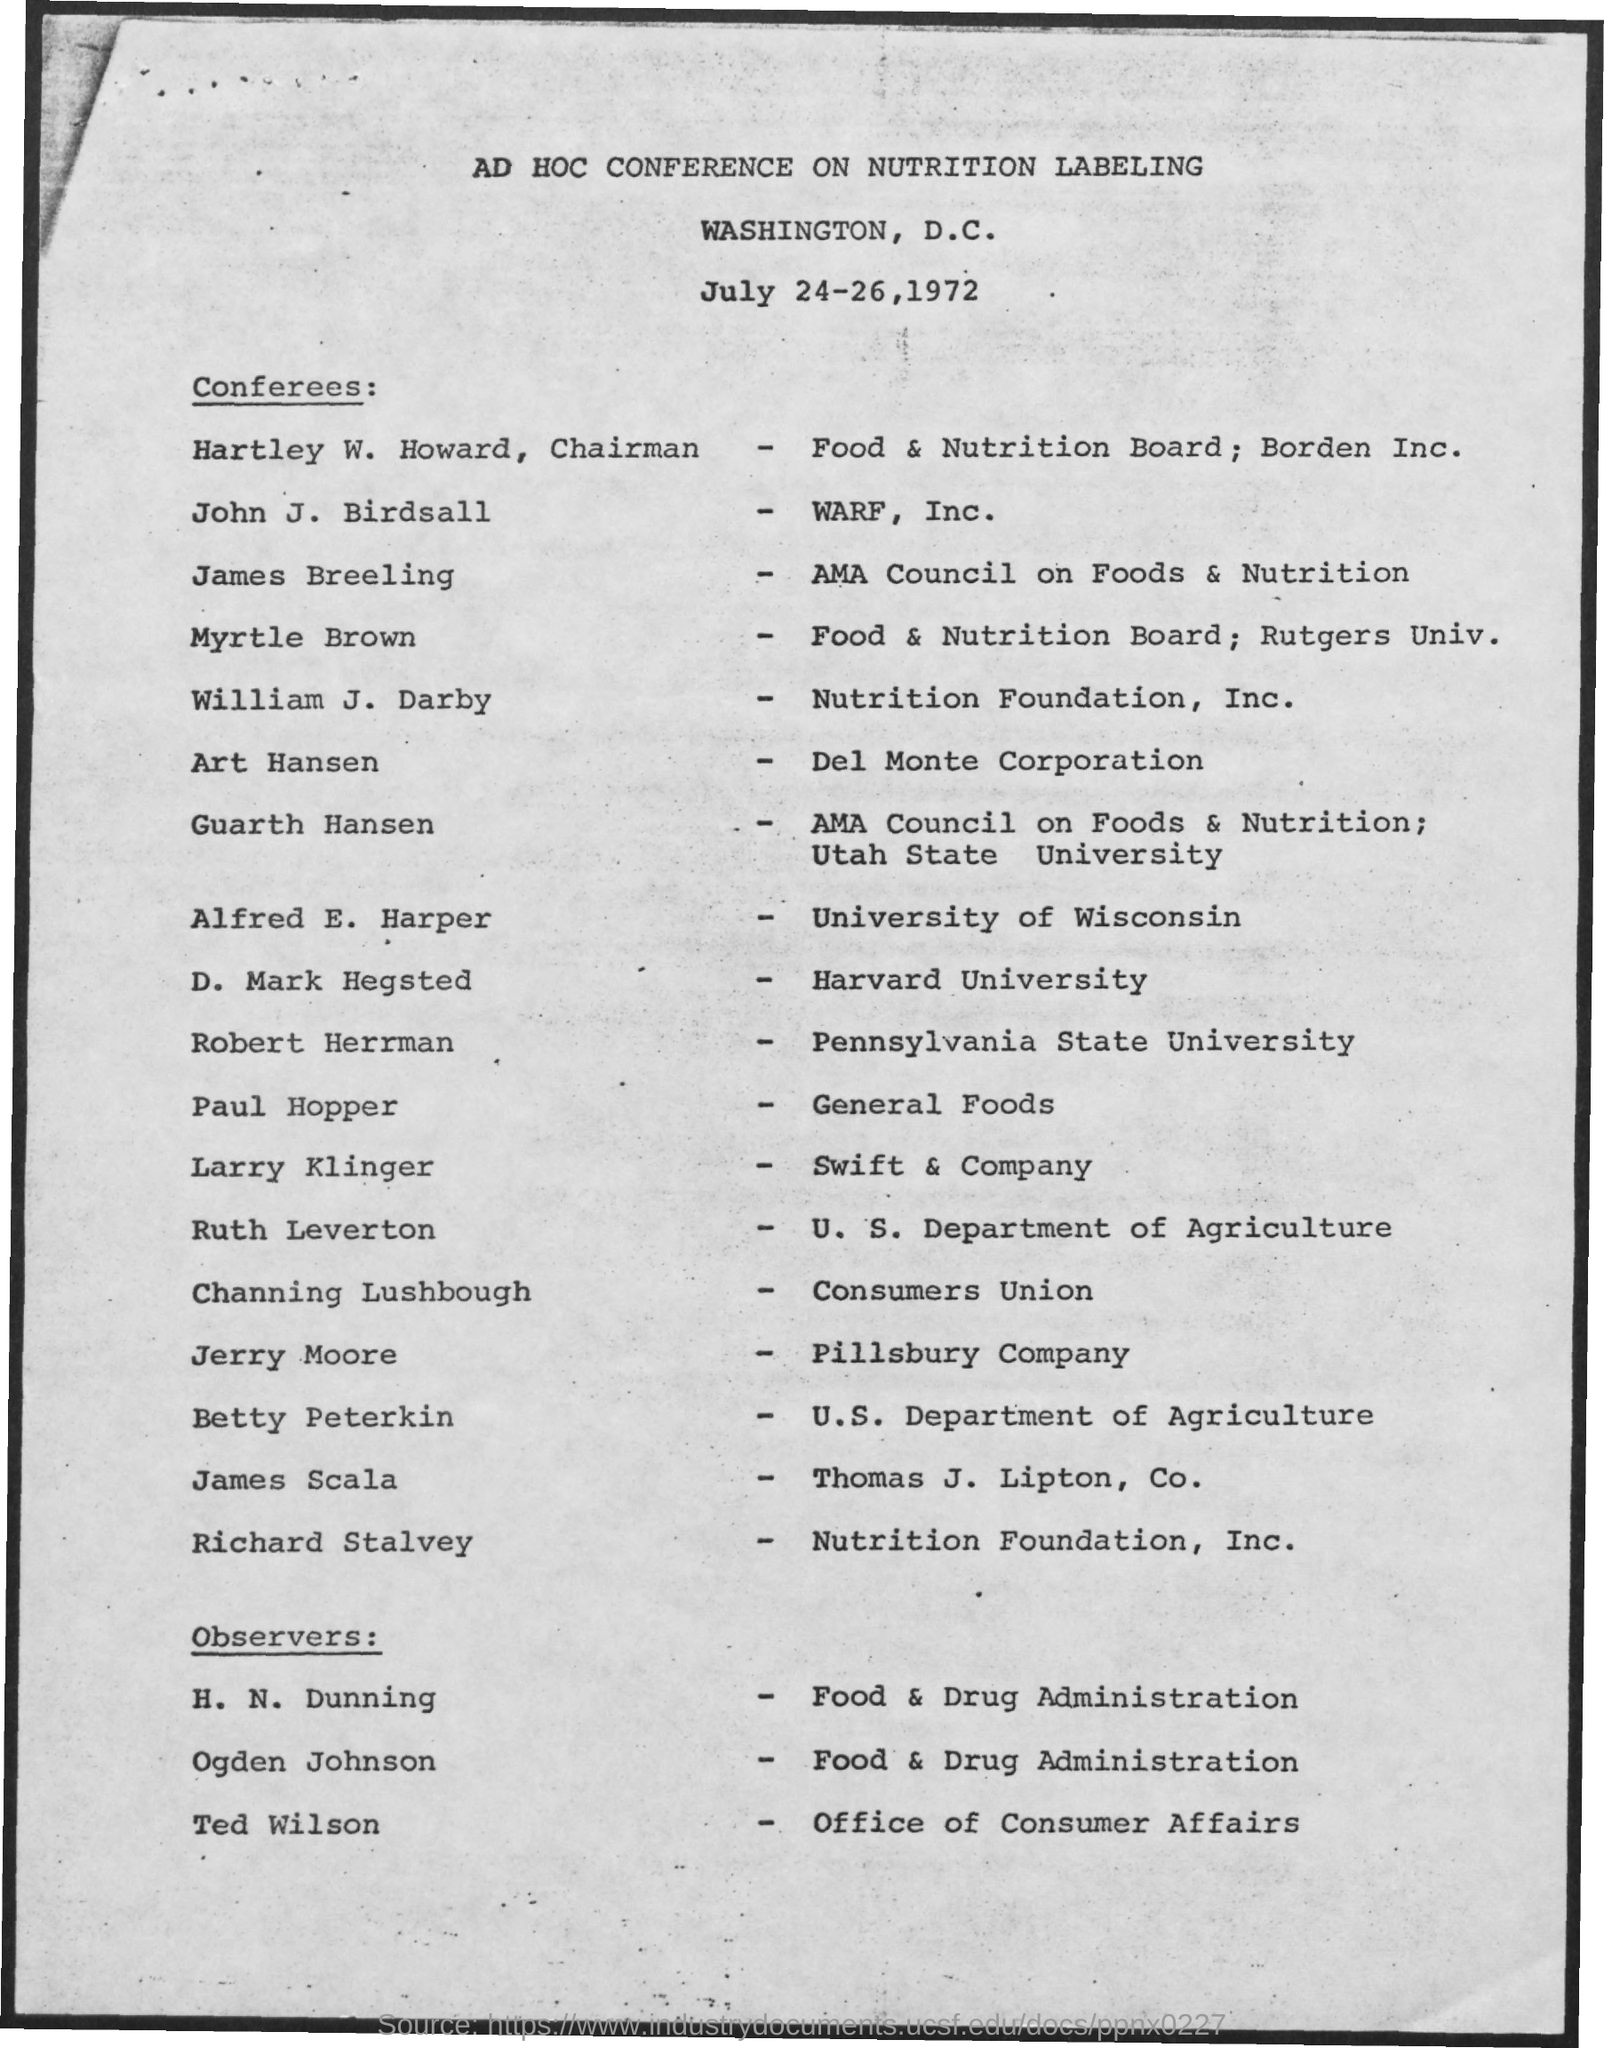Point out several critical features in this image. The observer of the office of Consumer Affairs is Ted Wilson. The conference on nutrition labeling was held in Washington, D.C. Betty Peterkin belongs to the U.S. Department of Agriculture. Jerry Moore belongs to the Pillsbury Company. D, Mark Hegsted belongs to Harvard University. 